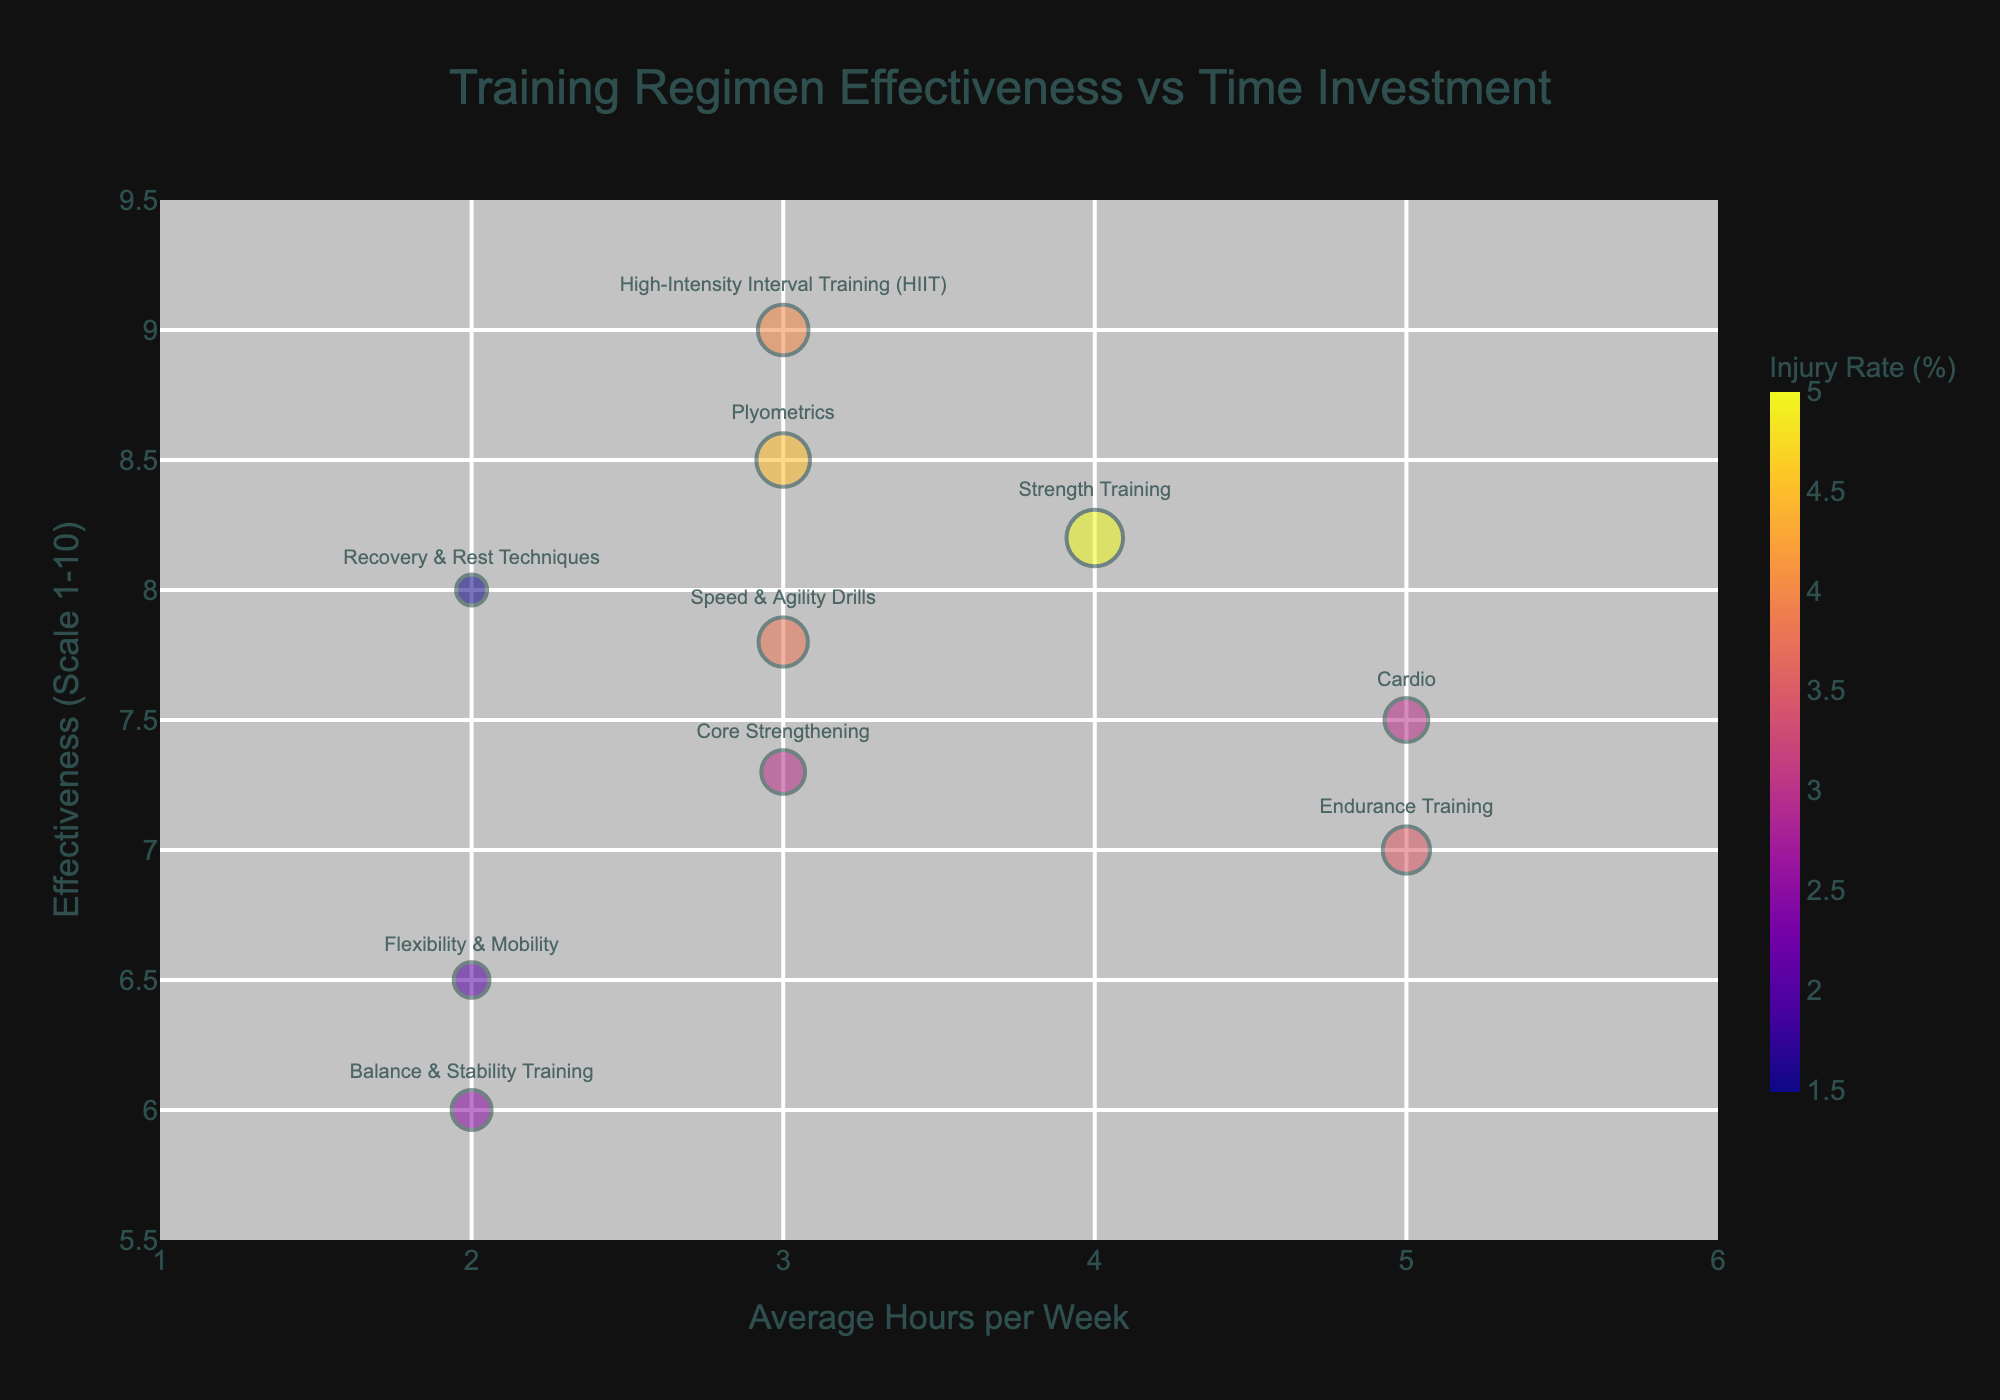What is the title of the figure? The title is displayed at the top center of the figure in a larger font. It reads "Training Regimen Effectiveness vs Time Investment".
Answer: Training Regimen Effectiveness vs Time Investment What does the x-axis represent? The label for the x-axis is "Average Hours per Week", indicating it represents the average number of hours per week spent on each conditioning technique.
Answer: Average Hours per Week Which conditioning technique has the highest effectiveness? By looking at the y-axis which measures effectiveness on a scale from 1 to 10, the data point highest on this axis corresponds to "High-Intensity Interval Training (HIIT)".
Answer: High-Intensity Interval Training (HIIT) What is the average injury rate for conditioning techniques requiring 3 hours per week? Identify the techniques requiring 3 hours per week ("HIIT", "Plyometrics", "Speed & Agility Drills", "Core Strengthening"), then average their injury rates: (4 + 4.5 + 3.8 + 3) / 4 = 3.825%.
Answer: 3.825% Which two conditioning techniques have the least average hours per week? On the x-axis, the techniques farthest to the left represent the least hours. These are "Flexibility & Mobility" and "Recovery & Rest Techniques", each with 2 hours per week.
Answer: Flexibility & Mobility and Recovery & Rest Techniques Compare the effectiveness and injury rate between "Cardio" and "Strength Training". "Cardio" has an effectiveness of 7.5 and an injury rate of 3%. "Strength Training" has an effectiveness of 8.2 and an injury rate of 5%. Strength Training has higher effectiveness but a higher injury rate.
Answer: Strength Training has higher effectiveness and injury rate What is the range of effectiveness values represented in the figure? Look at the y-axis to determine the spread of effectiveness values. They range from "Flexibility & Mobility" at 6.5 to "HIIT" at 9.
Answer: 6.5 to 9 Which conditioning technique has the lowest injury rate, and what is its effectiveness? The color bar shows that the smallest bubble, "Recovery & Rest Techniques", has the lowest injury rate (1.5%), and its effectiveness is 8.
Answer: Recovery & Rest Techniques, effectiveness 8 What is the average effectiveness of all conditioning techniques? Sum all effectiveness scores and divide by the number of techniques: (7.5 + 8.2 + 9 + 6.5 + 7 + 8.5 + 7.8 + 6 + 7.3 + 8) / 10 = 7.58.
Answer: 7.58 How does injury rate correlate with effectiveness? Observe bubble sizes and y-axis positions: larger bubbles (higher injury rates) tend to correspond to slightly higher effectiveness scores, suggesting a moderate positive correlation.
Answer: Positive correlation 